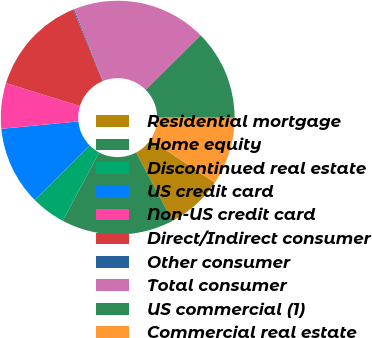Convert chart. <chart><loc_0><loc_0><loc_500><loc_500><pie_chart><fcel>Residential mortgage<fcel>Home equity<fcel>Discontinued real estate<fcel>US credit card<fcel>Non-US credit card<fcel>Direct/Indirect consumer<fcel>Other consumer<fcel>Total consumer<fcel>US commercial (1)<fcel>Commercial real estate<nl><fcel>7.84%<fcel>15.55%<fcel>4.76%<fcel>10.92%<fcel>6.3%<fcel>14.01%<fcel>0.14%<fcel>18.63%<fcel>12.47%<fcel>9.38%<nl></chart> 